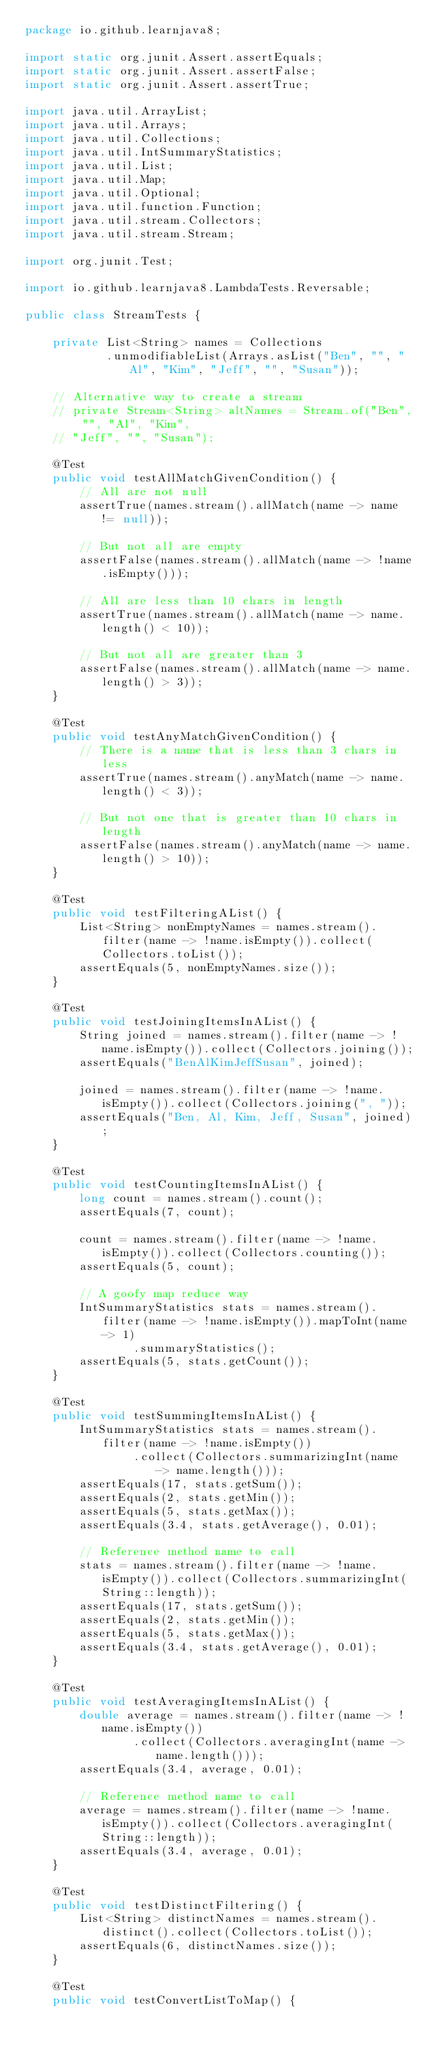<code> <loc_0><loc_0><loc_500><loc_500><_Java_>package io.github.learnjava8;

import static org.junit.Assert.assertEquals;
import static org.junit.Assert.assertFalse;
import static org.junit.Assert.assertTrue;

import java.util.ArrayList;
import java.util.Arrays;
import java.util.Collections;
import java.util.IntSummaryStatistics;
import java.util.List;
import java.util.Map;
import java.util.Optional;
import java.util.function.Function;
import java.util.stream.Collectors;
import java.util.stream.Stream;

import org.junit.Test;

import io.github.learnjava8.LambdaTests.Reversable;

public class StreamTests {

	private List<String> names = Collections
			.unmodifiableList(Arrays.asList("Ben", "", "Al", "Kim", "Jeff", "", "Susan"));

	// Alternative way to create a stream
	// private Stream<String> altNames = Stream.of("Ben", "", "Al", "Kim",
	// "Jeff", "", "Susan");

	@Test
	public void testAllMatchGivenCondition() {
		// All are not null
		assertTrue(names.stream().allMatch(name -> name != null));

		// But not all are empty
		assertFalse(names.stream().allMatch(name -> !name.isEmpty()));

		// All are less than 10 chars in length
		assertTrue(names.stream().allMatch(name -> name.length() < 10));

		// But not all are greater than 3
		assertFalse(names.stream().allMatch(name -> name.length() > 3));
	}

	@Test
	public void testAnyMatchGivenCondition() {
		// There is a name that is less than 3 chars in less
		assertTrue(names.stream().anyMatch(name -> name.length() < 3));

		// But not one that is greater than 10 chars in length
		assertFalse(names.stream().anyMatch(name -> name.length() > 10));
	}

	@Test
	public void testFilteringAList() {
		List<String> nonEmptyNames = names.stream().filter(name -> !name.isEmpty()).collect(Collectors.toList());
		assertEquals(5, nonEmptyNames.size());
	}

	@Test
	public void testJoiningItemsInAList() {
		String joined = names.stream().filter(name -> !name.isEmpty()).collect(Collectors.joining());
		assertEquals("BenAlKimJeffSusan", joined);

		joined = names.stream().filter(name -> !name.isEmpty()).collect(Collectors.joining(", "));
		assertEquals("Ben, Al, Kim, Jeff, Susan", joined);
	}

	@Test
	public void testCountingItemsInAList() {
		long count = names.stream().count();
		assertEquals(7, count);

		count = names.stream().filter(name -> !name.isEmpty()).collect(Collectors.counting());
		assertEquals(5, count);

		// A goofy map reduce way
		IntSummaryStatistics stats = names.stream().filter(name -> !name.isEmpty()).mapToInt(name -> 1)
				.summaryStatistics();
		assertEquals(5, stats.getCount());
	}

	@Test
	public void testSummingItemsInAList() {
		IntSummaryStatistics stats = names.stream().filter(name -> !name.isEmpty())
				.collect(Collectors.summarizingInt(name -> name.length()));
		assertEquals(17, stats.getSum());
		assertEquals(2, stats.getMin());
		assertEquals(5, stats.getMax());
		assertEquals(3.4, stats.getAverage(), 0.01);

		// Reference method name to call
		stats = names.stream().filter(name -> !name.isEmpty()).collect(Collectors.summarizingInt(String::length));
		assertEquals(17, stats.getSum());
		assertEquals(2, stats.getMin());
		assertEquals(5, stats.getMax());
		assertEquals(3.4, stats.getAverage(), 0.01);
	}

	@Test
	public void testAveragingItemsInAList() {
		double average = names.stream().filter(name -> !name.isEmpty())
				.collect(Collectors.averagingInt(name -> name.length()));
		assertEquals(3.4, average, 0.01);

		// Reference method name to call
		average = names.stream().filter(name -> !name.isEmpty()).collect(Collectors.averagingInt(String::length));
		assertEquals(3.4, average, 0.01);
	}

	@Test
	public void testDistinctFiltering() {
		List<String> distinctNames = names.stream().distinct().collect(Collectors.toList());
		assertEquals(6, distinctNames.size());
	}

	@Test
	public void testConvertListToMap() {</code> 